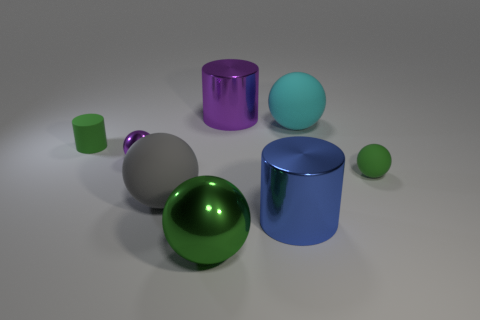Subtract all purple balls. How many balls are left? 4 Subtract all small green rubber spheres. How many spheres are left? 4 Subtract all blue balls. Subtract all brown cylinders. How many balls are left? 5 Add 2 big cyan spheres. How many objects exist? 10 Subtract all balls. How many objects are left? 3 Subtract all purple metallic balls. Subtract all small green matte objects. How many objects are left? 5 Add 6 small things. How many small things are left? 9 Add 3 cyan objects. How many cyan objects exist? 4 Subtract 1 green cylinders. How many objects are left? 7 